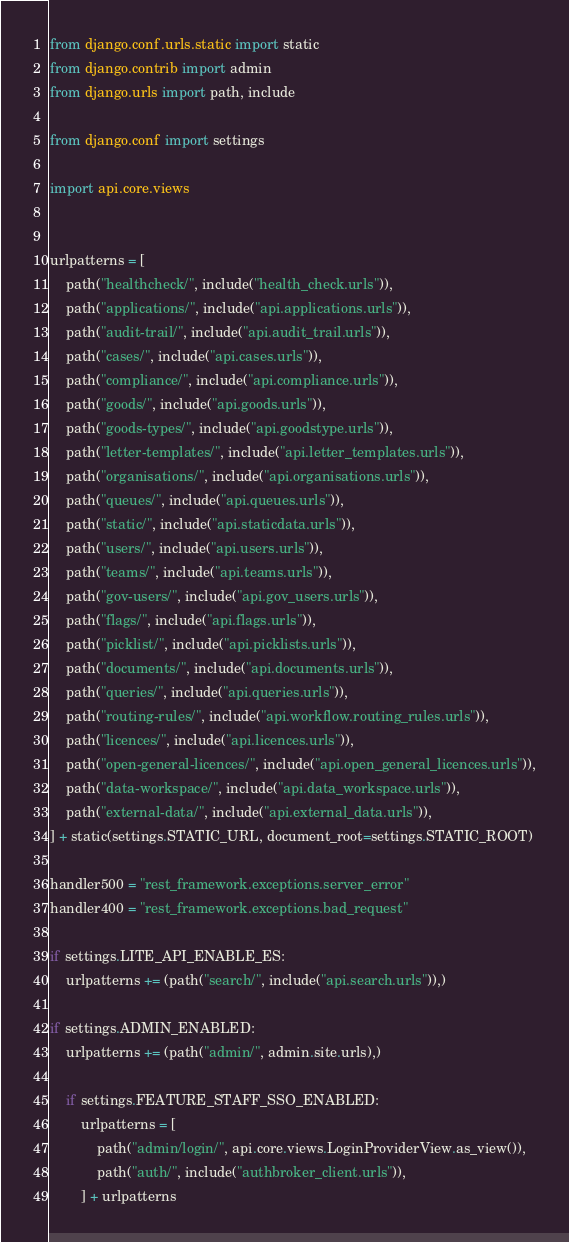<code> <loc_0><loc_0><loc_500><loc_500><_Python_>from django.conf.urls.static import static
from django.contrib import admin
from django.urls import path, include

from django.conf import settings

import api.core.views


urlpatterns = [
    path("healthcheck/", include("health_check.urls")),
    path("applications/", include("api.applications.urls")),
    path("audit-trail/", include("api.audit_trail.urls")),
    path("cases/", include("api.cases.urls")),
    path("compliance/", include("api.compliance.urls")),
    path("goods/", include("api.goods.urls")),
    path("goods-types/", include("api.goodstype.urls")),
    path("letter-templates/", include("api.letter_templates.urls")),
    path("organisations/", include("api.organisations.urls")),
    path("queues/", include("api.queues.urls")),
    path("static/", include("api.staticdata.urls")),
    path("users/", include("api.users.urls")),
    path("teams/", include("api.teams.urls")),
    path("gov-users/", include("api.gov_users.urls")),
    path("flags/", include("api.flags.urls")),
    path("picklist/", include("api.picklists.urls")),
    path("documents/", include("api.documents.urls")),
    path("queries/", include("api.queries.urls")),
    path("routing-rules/", include("api.workflow.routing_rules.urls")),
    path("licences/", include("api.licences.urls")),
    path("open-general-licences/", include("api.open_general_licences.urls")),
    path("data-workspace/", include("api.data_workspace.urls")),
    path("external-data/", include("api.external_data.urls")),
] + static(settings.STATIC_URL, document_root=settings.STATIC_ROOT)

handler500 = "rest_framework.exceptions.server_error"
handler400 = "rest_framework.exceptions.bad_request"

if settings.LITE_API_ENABLE_ES:
    urlpatterns += (path("search/", include("api.search.urls")),)

if settings.ADMIN_ENABLED:
    urlpatterns += (path("admin/", admin.site.urls),)

    if settings.FEATURE_STAFF_SSO_ENABLED:
        urlpatterns = [
            path("admin/login/", api.core.views.LoginProviderView.as_view()),
            path("auth/", include("authbroker_client.urls")),
        ] + urlpatterns
</code> 